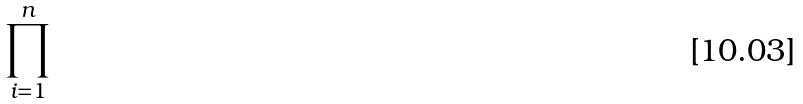Convert formula to latex. <formula><loc_0><loc_0><loc_500><loc_500>\prod _ { i = 1 } ^ { n }</formula> 